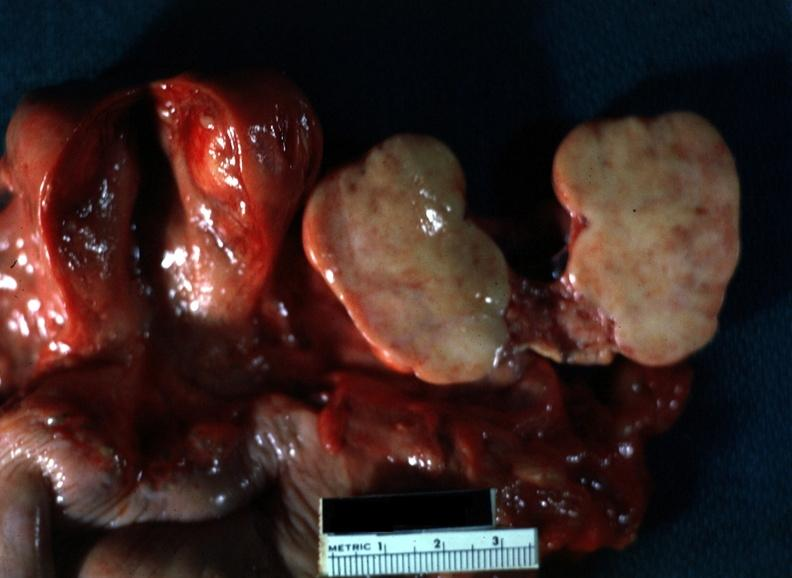what is present?
Answer the question using a single word or phrase. Female reproductive 